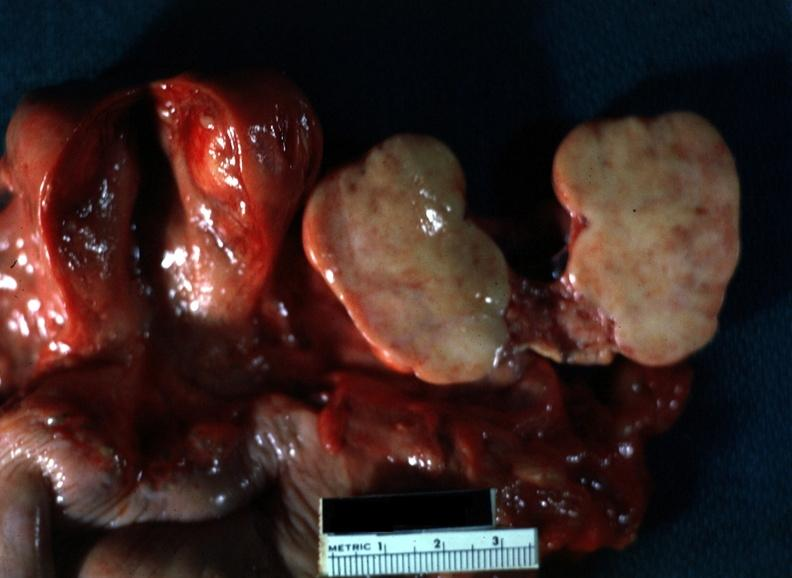what is present?
Answer the question using a single word or phrase. Female reproductive 